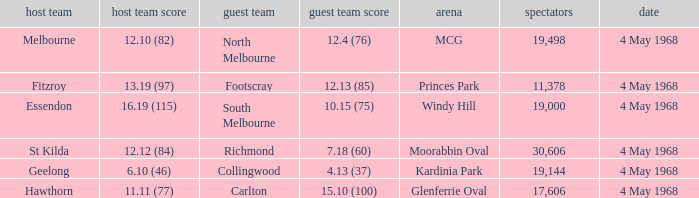What home team played at MCG? North Melbourne. 